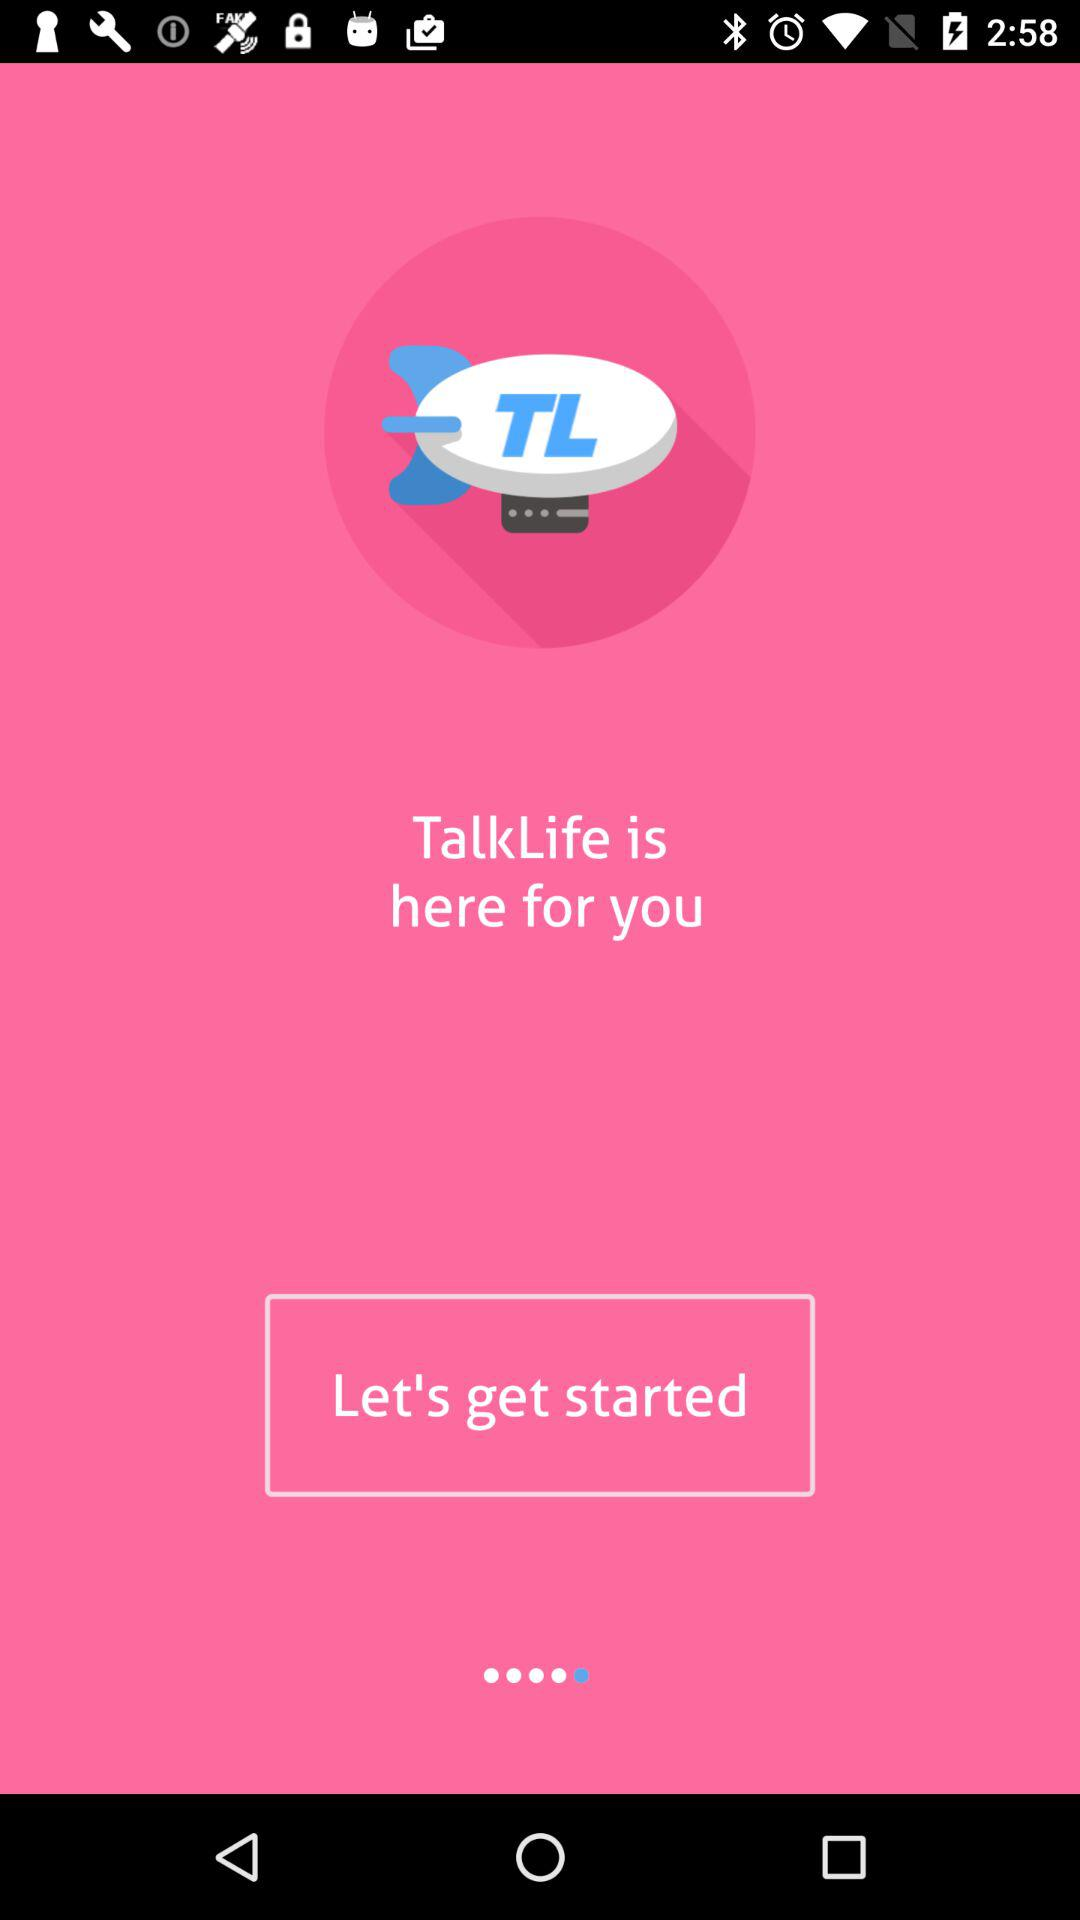What is the application name? The application name is "TalkLife". 